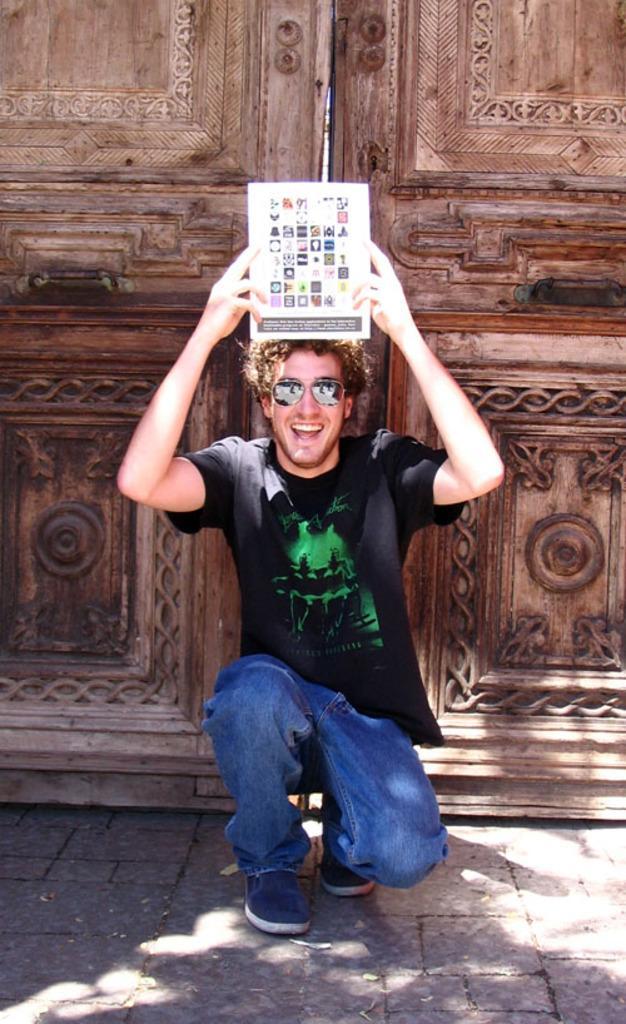Please provide a concise description of this image. In this image we can see a man wearing black T-shirt, blue jeans, shoes and glasses is smiling and is in the squat position while holding an object on the top of his head. In the background, we can see the wooden doors. 